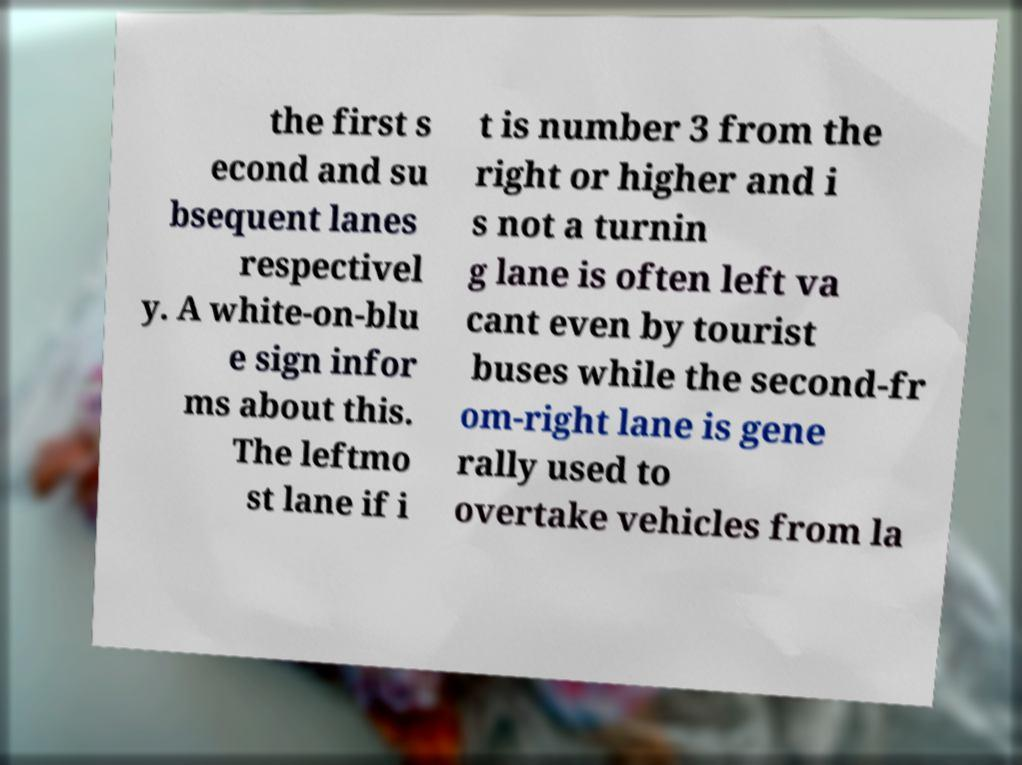Could you extract and type out the text from this image? the first s econd and su bsequent lanes respectivel y. A white-on-blu e sign infor ms about this. The leftmo st lane if i t is number 3 from the right or higher and i s not a turnin g lane is often left va cant even by tourist buses while the second-fr om-right lane is gene rally used to overtake vehicles from la 